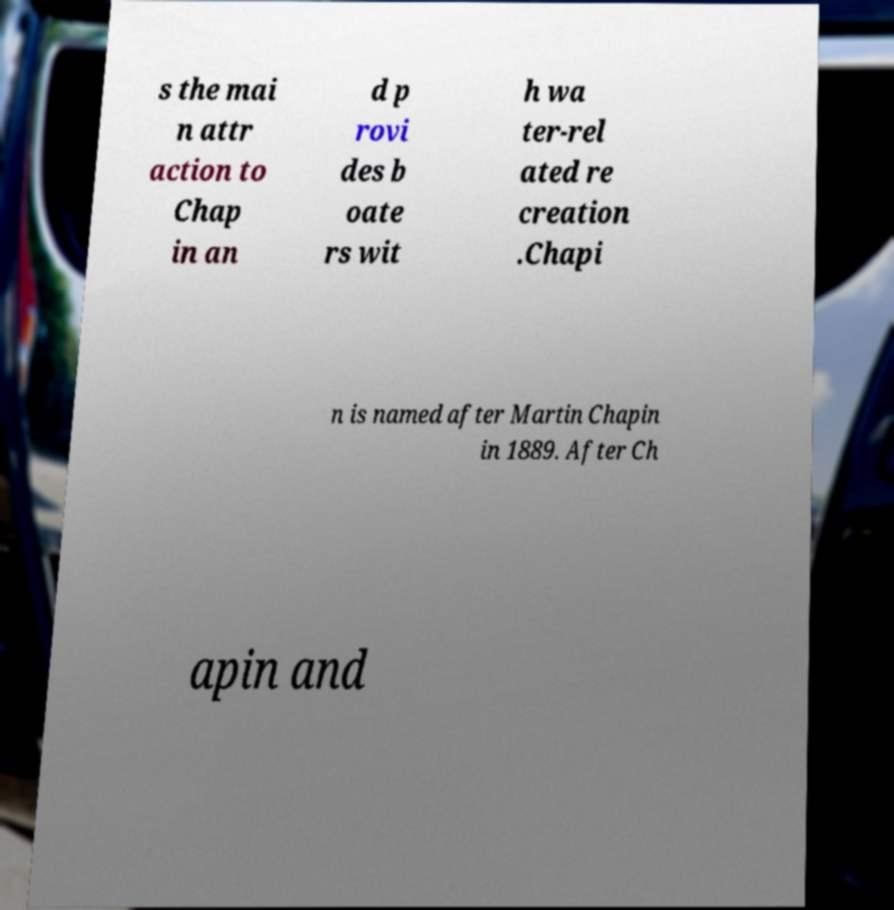Could you assist in decoding the text presented in this image and type it out clearly? s the mai n attr action to Chap in an d p rovi des b oate rs wit h wa ter-rel ated re creation .Chapi n is named after Martin Chapin in 1889. After Ch apin and 